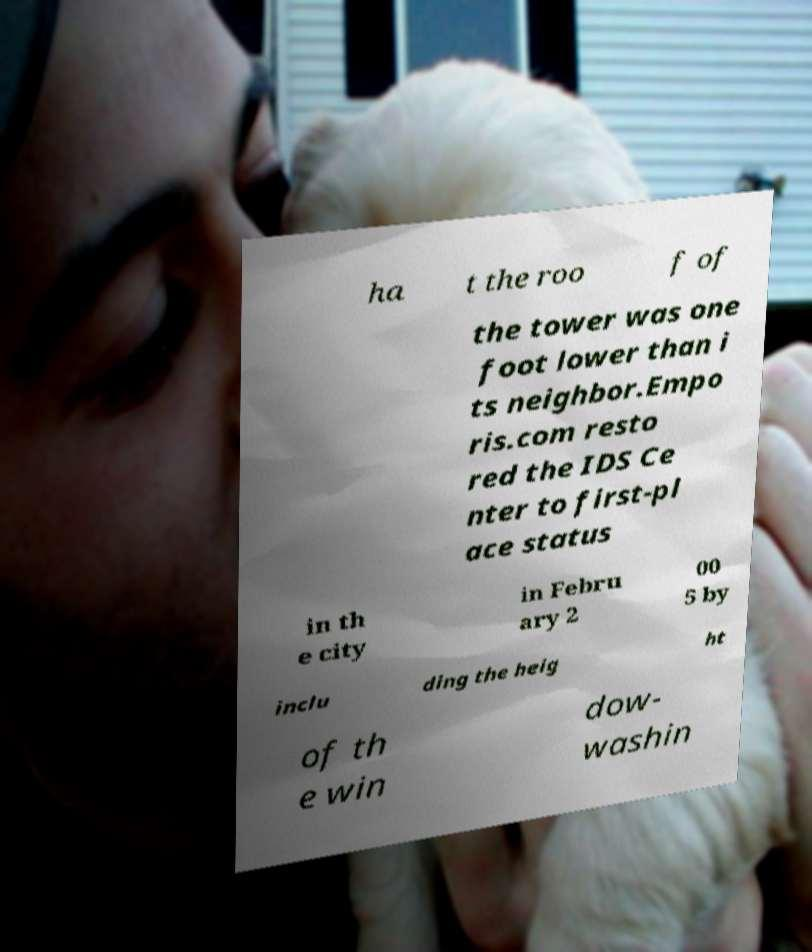Can you accurately transcribe the text from the provided image for me? ha t the roo f of the tower was one foot lower than i ts neighbor.Empo ris.com resto red the IDS Ce nter to first-pl ace status in th e city in Febru ary 2 00 5 by inclu ding the heig ht of th e win dow- washin 